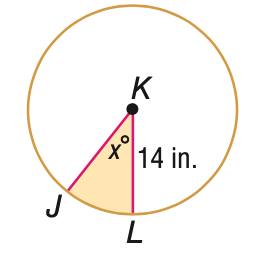Answer the mathemtical geometry problem and directly provide the correct option letter.
Question: The area A of the shaded region is given. Find x. A = 94 in^2.
Choices: A: 5.5 B: 27.5 C: 55.0 D: 110.0 C 